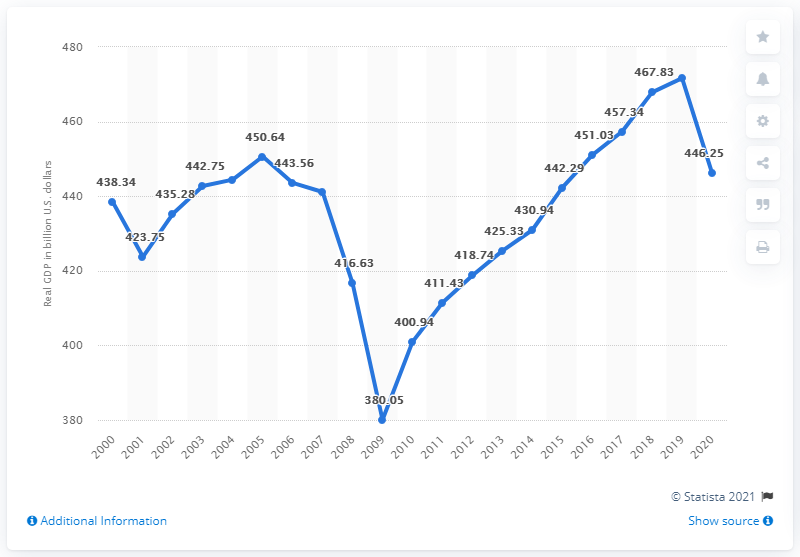Specify some key components in this picture. In 2020, the gross domestic product (GDP) of the state of Michigan was 446.25. In the previous year, Michigan's Gross Domestic Product (GDP) was 471.65 billion dollars. 